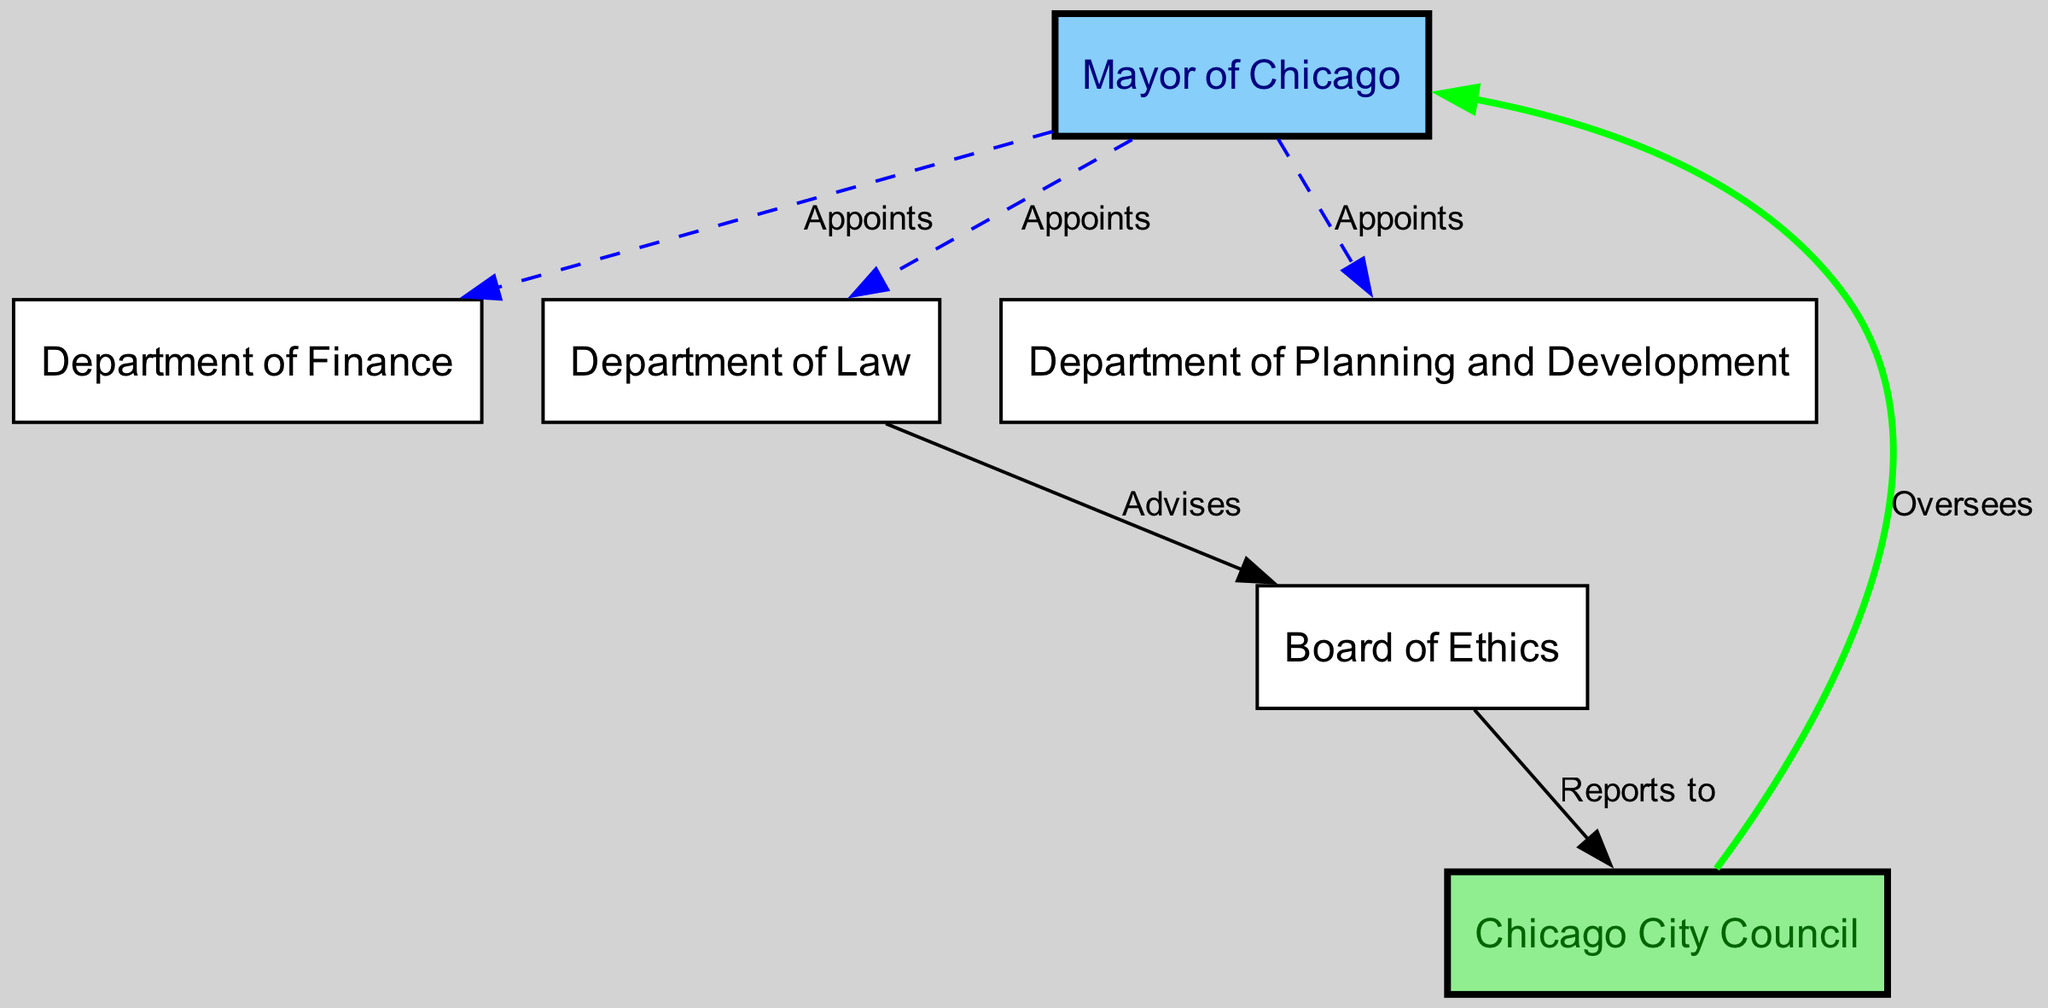What is the total number of nodes in the diagram? The diagram lists the following nodes: Mayor of Chicago, Chicago City Council, Department of Finance, Department of Law, Department of Planning and Development, and Board of Ethics. Counting these gives a total of 6 nodes.
Answer: 6 Who oversees the Mayor of Chicago? The diagram shows an edge from Chicago City Council to Mayor of Chicago with the label "Oversees". This indicates that the Chicago City Council has an oversight role over the Mayor.
Answer: Chicago City Council Which department advises the Board of Ethics? There is a directed edge from the Department of Law to the Board of Ethics labeled "Advises." This means that the Department of Law provides advice to the Board of Ethics.
Answer: Department of Law How many departments are appointed by the Mayor of Chicago? The diagram shows three distinct edges from the Mayor of Chicago to the Department of Finance, Department of Law, and Department of Planning and Development indicating that the Mayor appoints these three departments. Thus, the number is 3.
Answer: 3 To whom does the Board of Ethics report? The directed edge between the Board of Ethics and Chicago City Council labeled "Reports to" indicates that the Board of Ethics reports to the Chicago City Council.
Answer: Chicago City Council What is the relationship between the Mayor of Chicago and the Department of Planning and Development? The diagram indicates a directed edge from the Mayor of Chicago to the Department of Planning and Development, with the label "Appoints". This signifies that the Mayor appoints the head of the Department of Planning and Development.
Answer: Appoints Which two entities have a direct relationship in terms of advising and reporting? From the diagram, the Department of Law advises the Board of Ethics and the Board of Ethics reports to the Chicago City Council. This creates a flow of information from Department of Law to Board of Ethics to Chicago City Council. The two entities involved directly in this flow are the Department of Law and Chicago City Council.
Answer: Department of Law and Chicago City Council What type of graph is this? The diagram is characterized by directed edges showing the relationships between nodes with clear hierarchical and advisory connections. This structure makes it a Directed Graph.
Answer: Directed Graph 